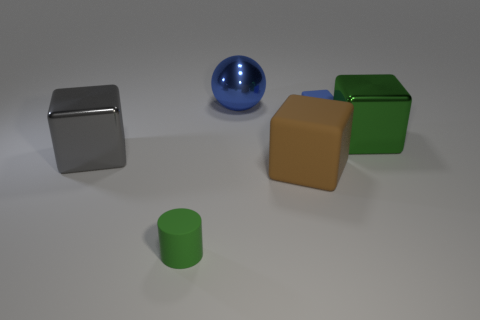Subtract all small matte cubes. How many cubes are left? 3 Subtract all green cubes. How many cubes are left? 3 Add 2 small green cylinders. How many objects exist? 8 Subtract all cylinders. How many objects are left? 5 Subtract 1 cubes. How many cubes are left? 3 Subtract all cyan balls. How many gray blocks are left? 1 Add 1 tiny blue rubber cylinders. How many tiny blue rubber cylinders exist? 1 Subtract 0 brown cylinders. How many objects are left? 6 Subtract all green blocks. Subtract all cyan cylinders. How many blocks are left? 3 Subtract all tiny blue matte objects. Subtract all green metallic things. How many objects are left? 4 